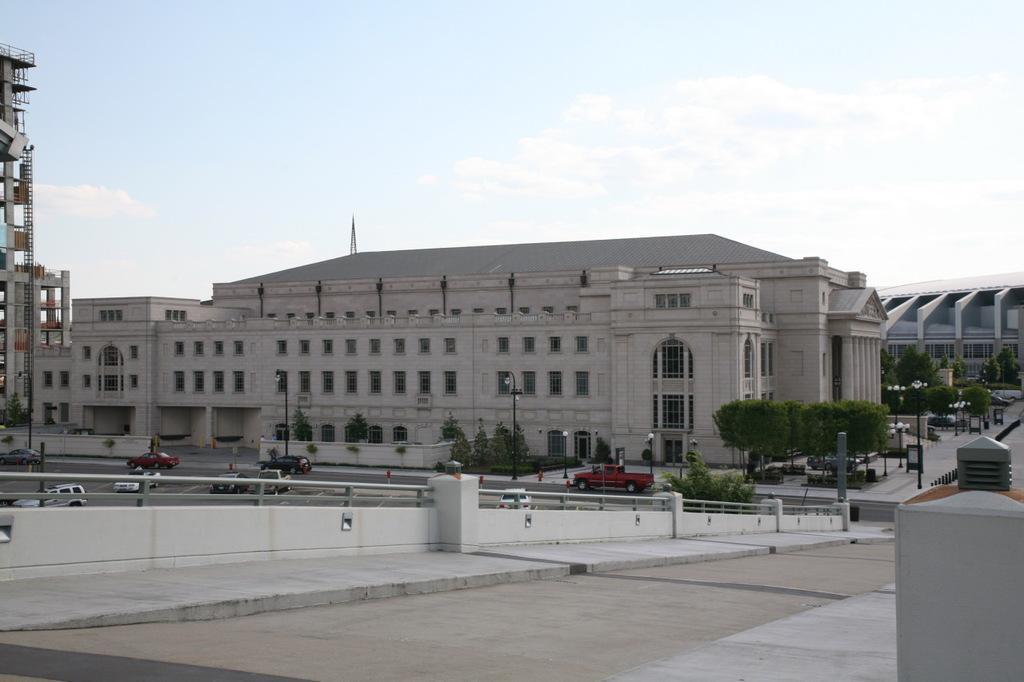How would you summarize this image in a sentence or two? This image is taken outdoors. At the top of the image there is a sky with clouds. At the bottom of the image there is a road and there is a sidewalk. In the middle of the image there is a railing. A few cars are moving on the road and a few are parked on the road. There are a few trees and plants and there are many buildings and poles with street lights. 